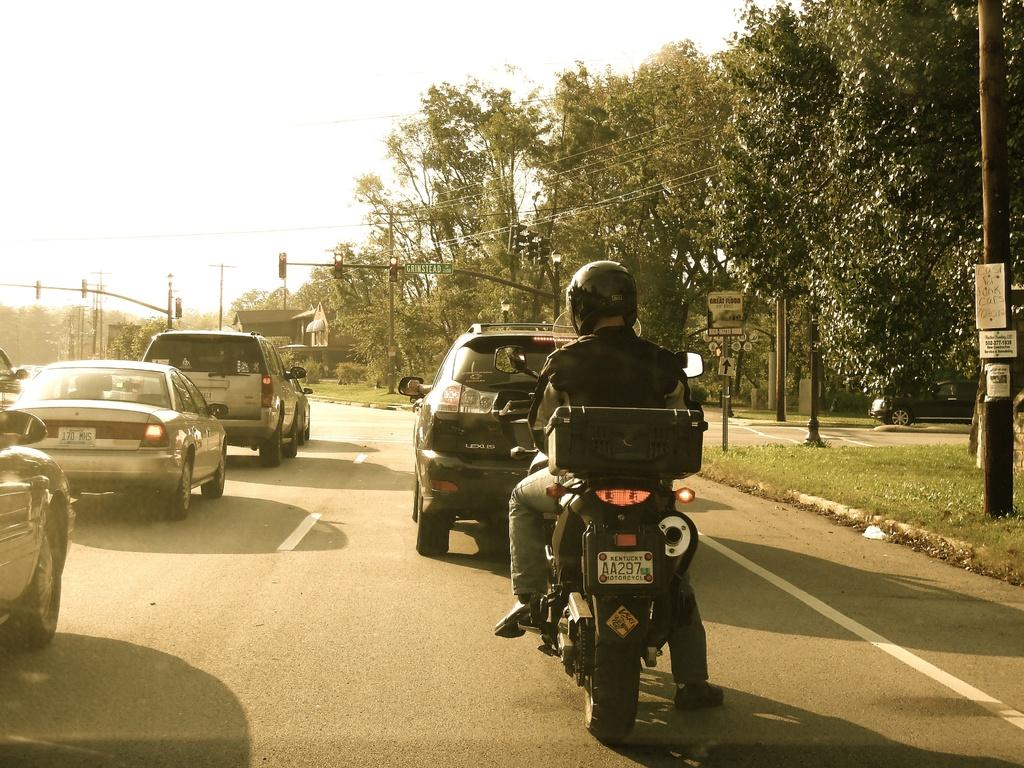What is the main object in the image? There is a bike in the image. Who is associated with the bike in the image? A person is sitting on the bike. What can be seen on the road in the image? There are cars on the road in the image. What is present in the background of the image? There are traffic signals and trees visible in the background of the image. What type of pipe is being used by the person sitting on the bike in the image? There is no pipe present in the image; the person is sitting on a bike. How many sticks are being held by the person sitting on the bike in the image? There are no sticks present in the image; the person is sitting on a bike. 